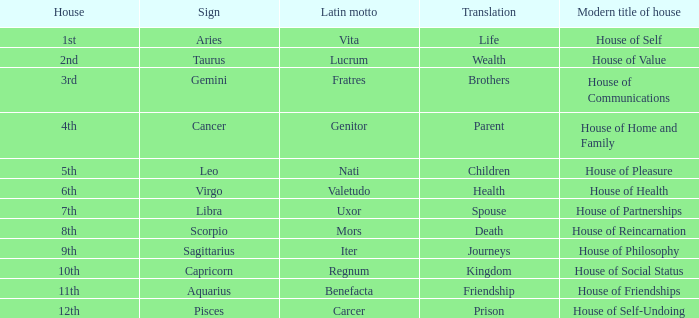Which star sign holds the latin motto of vita? Aries. 